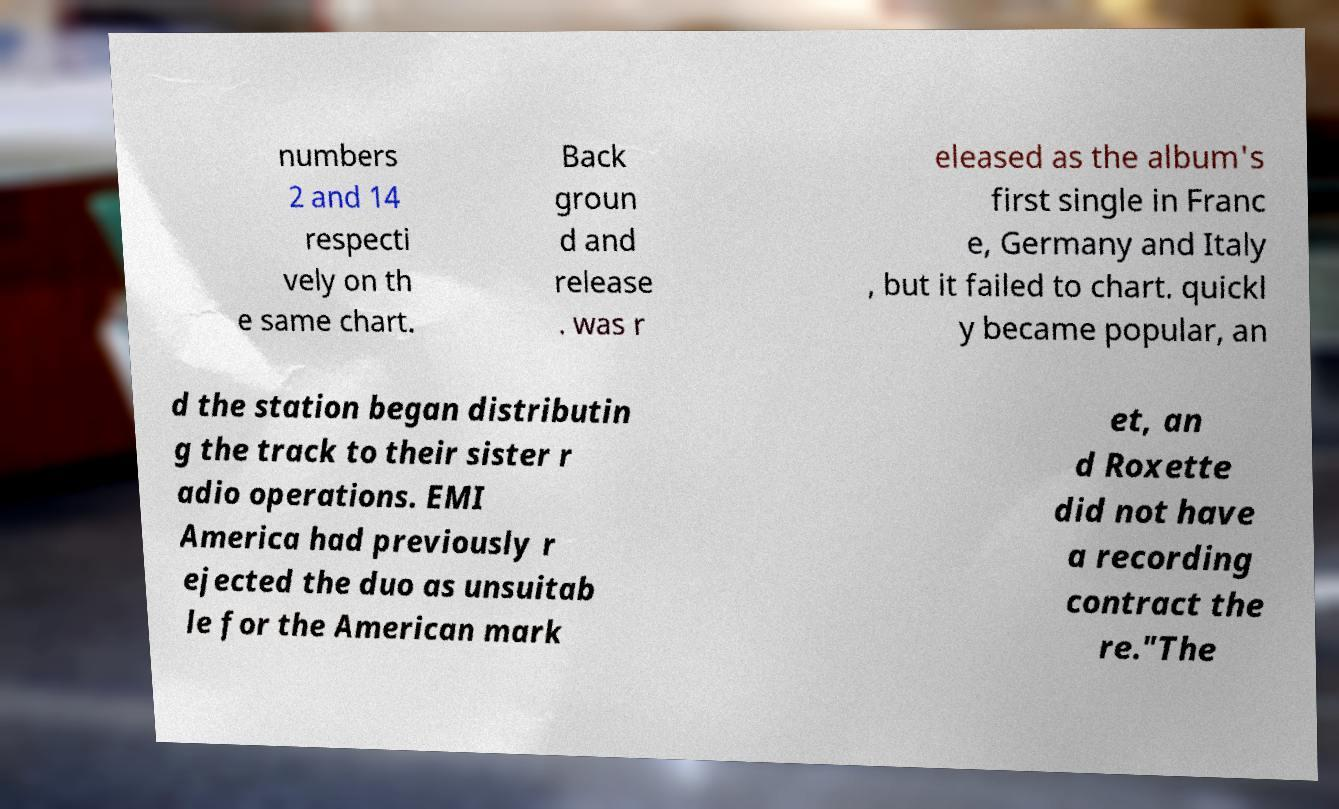Can you read and provide the text displayed in the image?This photo seems to have some interesting text. Can you extract and type it out for me? numbers 2 and 14 respecti vely on th e same chart. Back groun d and release . was r eleased as the album's first single in Franc e, Germany and Italy , but it failed to chart. quickl y became popular, an d the station began distributin g the track to their sister r adio operations. EMI America had previously r ejected the duo as unsuitab le for the American mark et, an d Roxette did not have a recording contract the re."The 